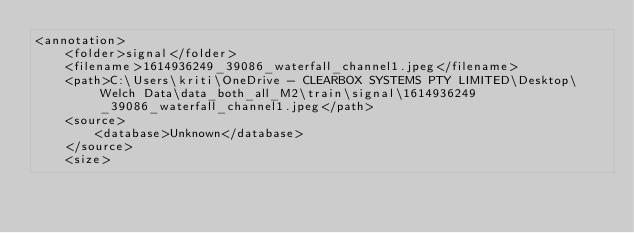Convert code to text. <code><loc_0><loc_0><loc_500><loc_500><_XML_><annotation>
    <folder>signal</folder>
    <filename>1614936249_39086_waterfall_channel1.jpeg</filename>
    <path>C:\Users\kriti\OneDrive - CLEARBOX SYSTEMS PTY LIMITED\Desktop\Welch Data\data_both_all_M2\train\signal\1614936249_39086_waterfall_channel1.jpeg</path>
    <source>
        <database>Unknown</database>
    </source>
    <size></code> 